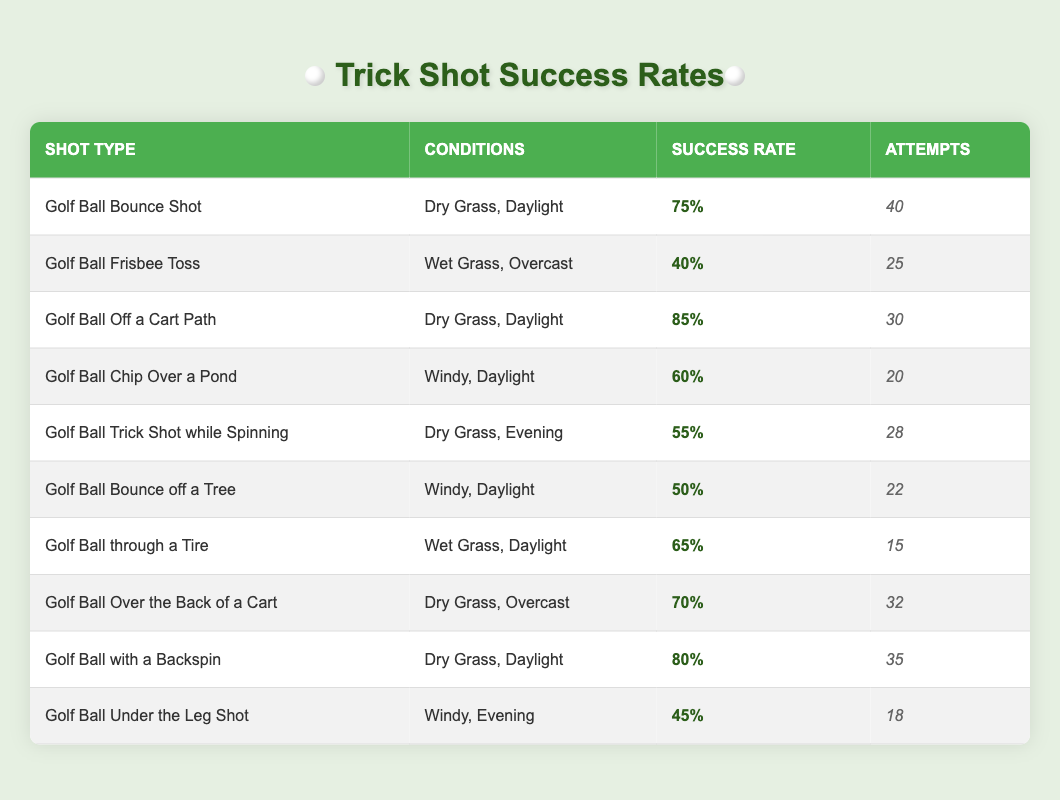What is the success rate of the Golf Ball Bounce Shot on Dry Grass, Daylight? According to the table, the success rate for the Golf Ball Bounce Shot under the conditions of Dry Grass and Daylight is found in the corresponding row: it states a success rate of 75%.
Answer: 75% How many attempts were made for the Golf Ball Chip Over a Pond? In the table, the row for Golf Ball Chip Over a Pond shows that there were 20 attempts recorded.
Answer: 20 Which shot had the highest success rate? By reviewing the success rates of all shots in the table, the Golf Ball Off a Cart Path has the highest success rate at 85%. This is verified by looking at the success rates listed for each shot type.
Answer: 85% What is the average success rate of shots attempted in Wet Grass conditions? The two shots attempted in Wet Grass are the Golf Ball Frisbee Toss (40%) and Golf Ball through a Tire (65%). To find the average, we add the success rates: (40 + 65) = 105, and then divide by the number of shots (2). Thus, the average success rate is 105/2 = 52.5%.
Answer: 52.5% Was the success rate for the Golf Ball Under the Leg Shot greater than 50%? The success rate for this shot is recorded as 45%. Since 45% is less than 50%, the statement is false.
Answer: No What is the difference in success rate between Golf Ball with a Backspin and Golf Ball Trick Shot while Spinning? The success rate for Golf Ball with a Backspin is 80%, and for Golf Ball Trick Shot while Spinning it is 55%. The difference is calculated as 80 - 55 = 25.
Answer: 25 In how many attempts did the Golf Ball Bounce off a Tree succeed? The success rate for the Golf Ball Bounce off a Tree is 50%. Given there were 22 attempts, we can calculate the number of successes by multiplying: 50% of 22 attempts is 11 successful shots.
Answer: 11 Which shot has a success rate less than 50%? From reviewing the table, the Golf Ball Frisbee Toss (40%) and Golf Ball Under the Leg Shot (45%) both have success rates below 50%. This is determined by comparing each shot’s success rate to the threshold of 50 percent.
Answer: Golf Ball Frisbee Toss and Golf Ball Under the Leg Shot What is the total number of attempts made for all shots listed? To find the total attempts, we need to sum up each attempt from the table: (40 + 25 + 30 + 20 + 28 + 22 + 15 + 32 + 35 + 18) =  300. Therefore, the total number of attempts made is 300.
Answer: 300 